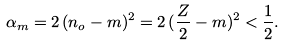Convert formula to latex. <formula><loc_0><loc_0><loc_500><loc_500>\alpha _ { m } = 2 \, ( n _ { o } - m ) ^ { 2 } = 2 \, ( \frac { Z } { 2 } - m ) ^ { 2 } < \frac { 1 } { 2 } .</formula> 